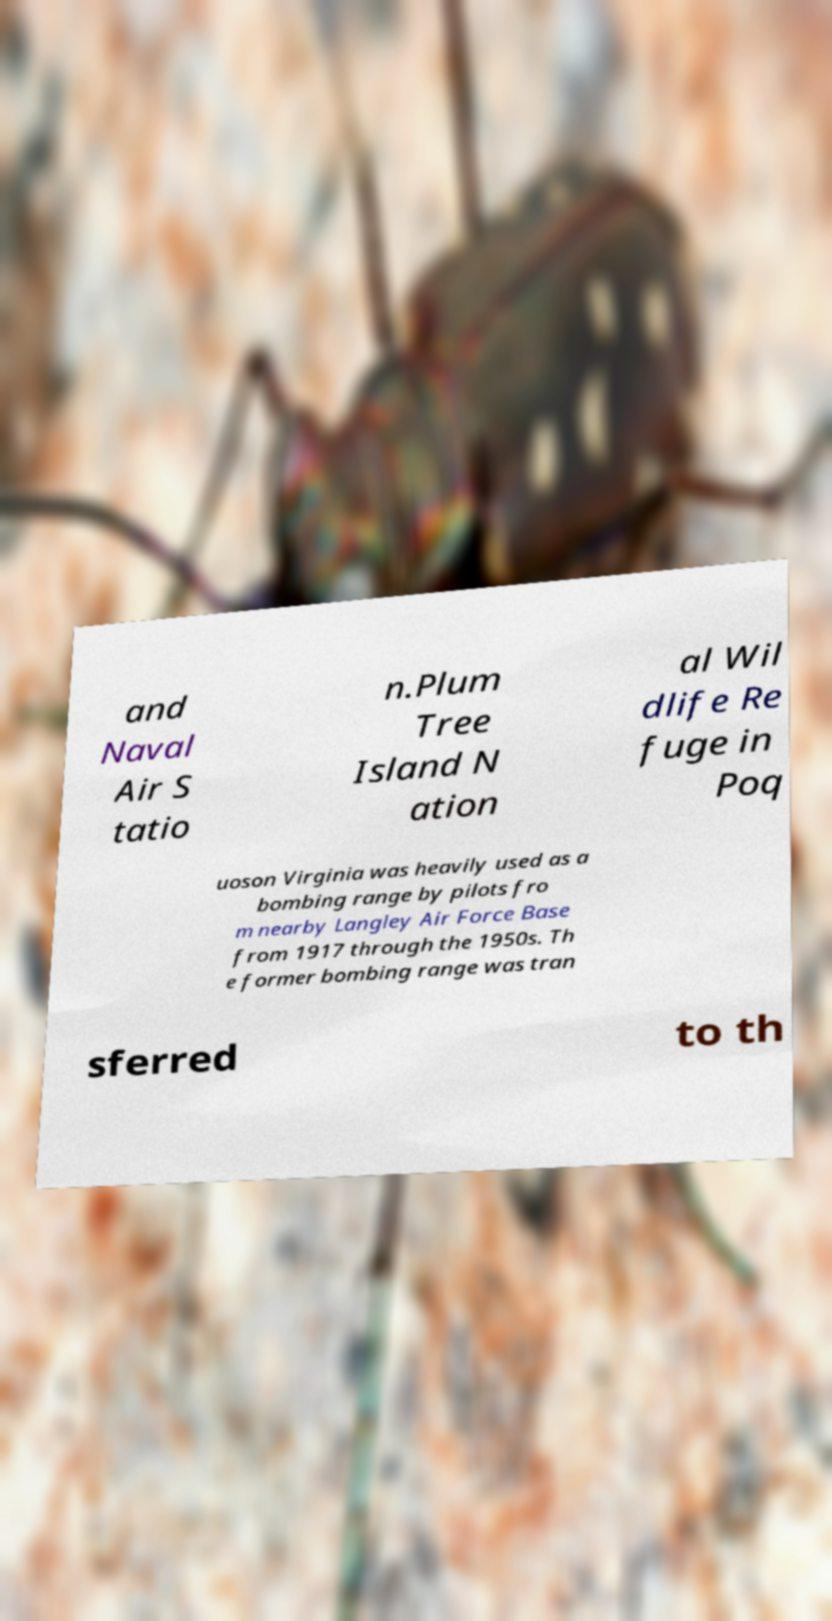Please read and relay the text visible in this image. What does it say? and Naval Air S tatio n.Plum Tree Island N ation al Wil dlife Re fuge in Poq uoson Virginia was heavily used as a bombing range by pilots fro m nearby Langley Air Force Base from 1917 through the 1950s. Th e former bombing range was tran sferred to th 